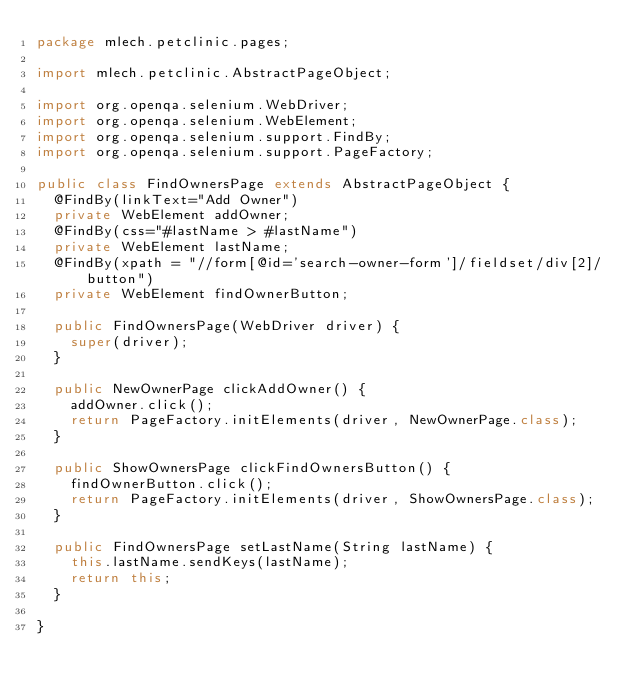<code> <loc_0><loc_0><loc_500><loc_500><_Java_>package mlech.petclinic.pages;

import mlech.petclinic.AbstractPageObject;

import org.openqa.selenium.WebDriver;
import org.openqa.selenium.WebElement;
import org.openqa.selenium.support.FindBy;
import org.openqa.selenium.support.PageFactory;

public class FindOwnersPage extends AbstractPageObject {
	@FindBy(linkText="Add Owner")
	private WebElement addOwner;
	@FindBy(css="#lastName > #lastName")
	private WebElement lastName;
	@FindBy(xpath = "//form[@id='search-owner-form']/fieldset/div[2]/button")
	private WebElement findOwnerButton;
	
	public FindOwnersPage(WebDriver driver) {
		super(driver);
	}
	
	public NewOwnerPage clickAddOwner() {
		addOwner.click();
		return PageFactory.initElements(driver, NewOwnerPage.class);
	}
	
	public ShowOwnersPage clickFindOwnersButton() {
		findOwnerButton.click();
		return PageFactory.initElements(driver, ShowOwnersPage.class);
	}

	public FindOwnersPage setLastName(String lastName) {
		this.lastName.sendKeys(lastName);
		return this;
	}

}
</code> 